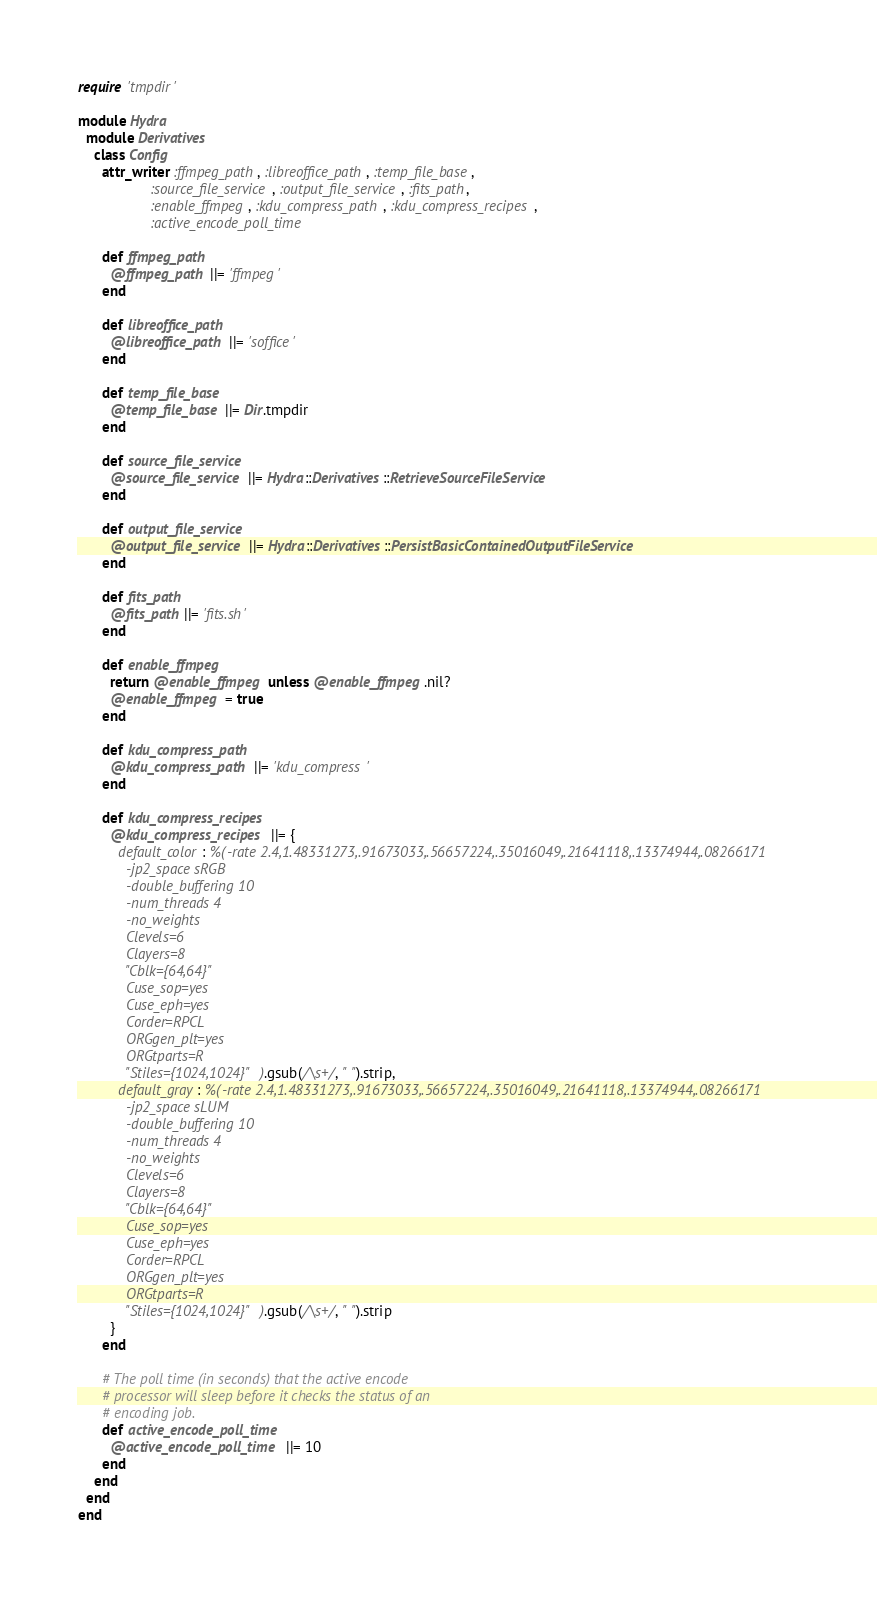<code> <loc_0><loc_0><loc_500><loc_500><_Ruby_>require 'tmpdir'

module Hydra
  module Derivatives
    class Config
      attr_writer :ffmpeg_path, :libreoffice_path, :temp_file_base,
                  :source_file_service, :output_file_service, :fits_path,
                  :enable_ffmpeg, :kdu_compress_path, :kdu_compress_recipes,
                  :active_encode_poll_time

      def ffmpeg_path
        @ffmpeg_path ||= 'ffmpeg'
      end

      def libreoffice_path
        @libreoffice_path ||= 'soffice'
      end

      def temp_file_base
        @temp_file_base ||= Dir.tmpdir
      end

      def source_file_service
        @source_file_service ||= Hydra::Derivatives::RetrieveSourceFileService
      end

      def output_file_service
        @output_file_service ||= Hydra::Derivatives::PersistBasicContainedOutputFileService
      end

      def fits_path
        @fits_path ||= 'fits.sh'
      end

      def enable_ffmpeg
        return @enable_ffmpeg unless @enable_ffmpeg.nil?
        @enable_ffmpeg = true
      end

      def kdu_compress_path
        @kdu_compress_path ||= 'kdu_compress'
      end

      def kdu_compress_recipes
        @kdu_compress_recipes ||= {
          default_color: %(-rate 2.4,1.48331273,.91673033,.56657224,.35016049,.21641118,.13374944,.08266171
            -jp2_space sRGB
            -double_buffering 10
            -num_threads 4
            -no_weights
            Clevels=6
            Clayers=8
            "Cblk={64,64}"
            Cuse_sop=yes
            Cuse_eph=yes
            Corder=RPCL
            ORGgen_plt=yes
            ORGtparts=R
            "Stiles={1024,1024}" ).gsub(/\s+/, " ").strip,
          default_gray: %(-rate 2.4,1.48331273,.91673033,.56657224,.35016049,.21641118,.13374944,.08266171
            -jp2_space sLUM
            -double_buffering 10
            -num_threads 4
            -no_weights
            Clevels=6
            Clayers=8
            "Cblk={64,64}"
            Cuse_sop=yes
            Cuse_eph=yes
            Corder=RPCL
            ORGgen_plt=yes
            ORGtparts=R
            "Stiles={1024,1024}" ).gsub(/\s+/, " ").strip
        }
      end

      # The poll time (in seconds) that the active encode
      # processor will sleep before it checks the status of an
      # encoding job.
      def active_encode_poll_time
        @active_encode_poll_time ||= 10
      end
    end
  end
end
</code> 